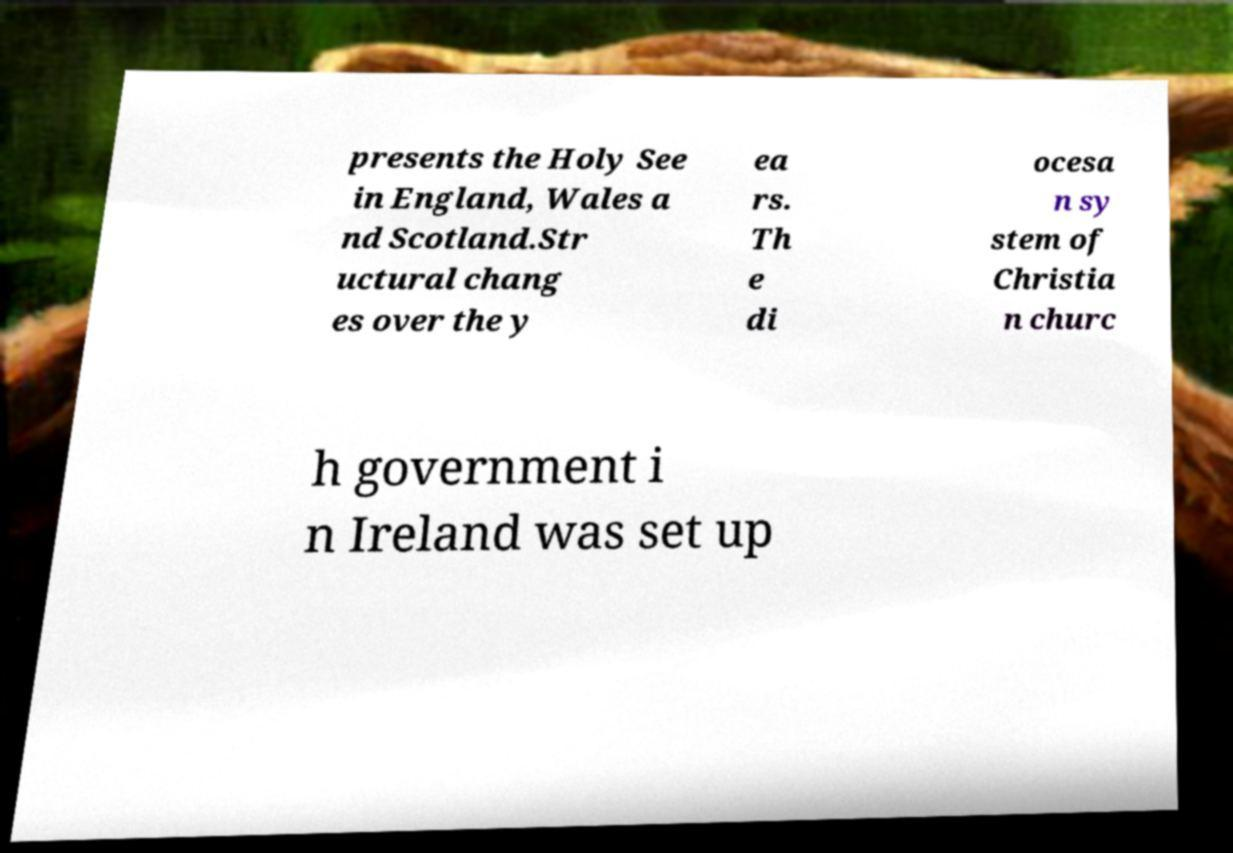Can you read and provide the text displayed in the image?This photo seems to have some interesting text. Can you extract and type it out for me? presents the Holy See in England, Wales a nd Scotland.Str uctural chang es over the y ea rs. Th e di ocesa n sy stem of Christia n churc h government i n Ireland was set up 